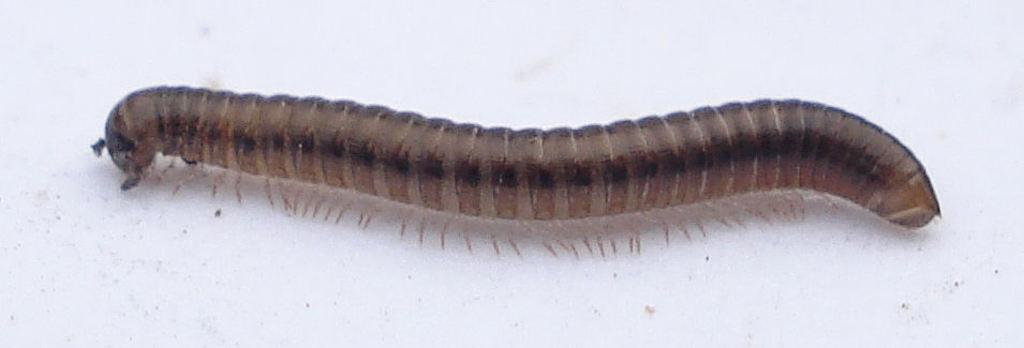What type of animal is in the image? There is a snail in the image. Where is the snail located in the image? The snail is on either the wall or the floor. What type of tooth can be seen in the image? There is no tooth present in the image; it features a snail on either the wall or the floor. Is there a cave visible in the image? There is no cave present in the image; it features a snail on either the wall or the floor. 